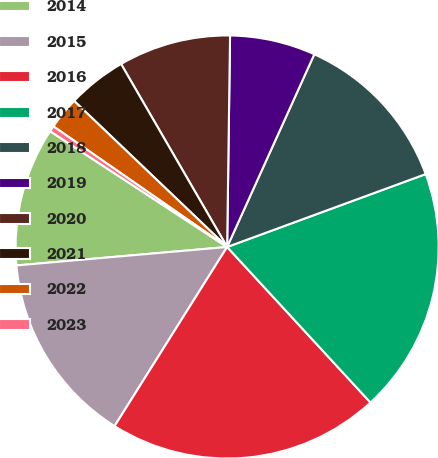Convert chart. <chart><loc_0><loc_0><loc_500><loc_500><pie_chart><fcel>2014<fcel>2015<fcel>2016<fcel>2017<fcel>2018<fcel>2019<fcel>2020<fcel>2021<fcel>2022<fcel>2023<nl><fcel>10.61%<fcel>14.68%<fcel>20.78%<fcel>18.75%<fcel>12.64%<fcel>6.54%<fcel>8.58%<fcel>4.51%<fcel>2.47%<fcel>0.44%<nl></chart> 